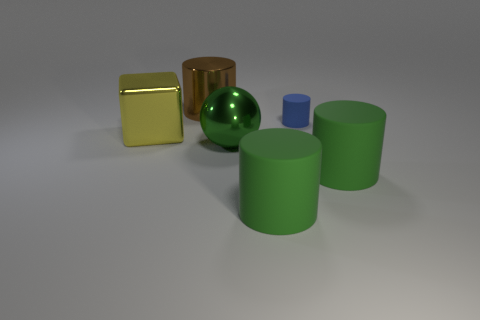Add 1 large gray cubes. How many objects exist? 7 Subtract all spheres. How many objects are left? 5 Add 3 large green things. How many large green things exist? 6 Subtract 0 gray cubes. How many objects are left? 6 Subtract all tiny red balls. Subtract all small blue things. How many objects are left? 5 Add 6 big yellow things. How many big yellow things are left? 7 